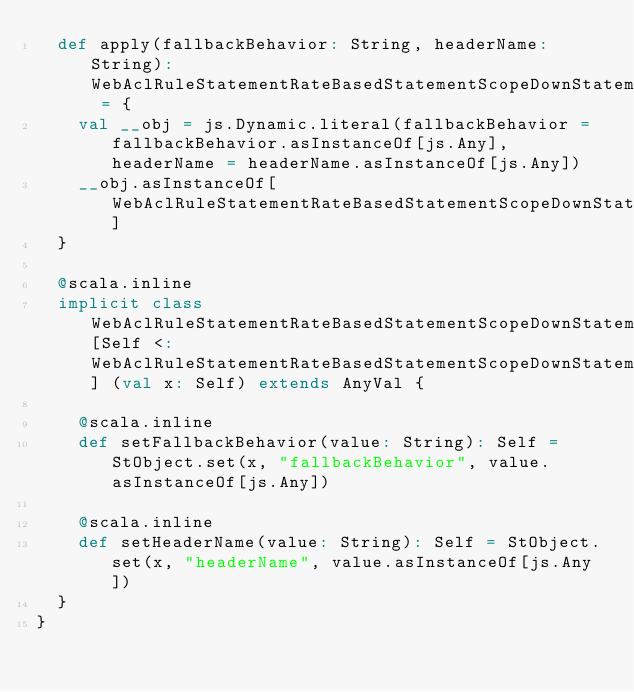<code> <loc_0><loc_0><loc_500><loc_500><_Scala_>  def apply(fallbackBehavior: String, headerName: String): WebAclRuleStatementRateBasedStatementScopeDownStatementNotStatementStatementNotStatementStatementGeoMatchStatementForwardedIpConfig = {
    val __obj = js.Dynamic.literal(fallbackBehavior = fallbackBehavior.asInstanceOf[js.Any], headerName = headerName.asInstanceOf[js.Any])
    __obj.asInstanceOf[WebAclRuleStatementRateBasedStatementScopeDownStatementNotStatementStatementNotStatementStatementGeoMatchStatementForwardedIpConfig]
  }
  
  @scala.inline
  implicit class WebAclRuleStatementRateBasedStatementScopeDownStatementNotStatementStatementNotStatementStatementGeoMatchStatementForwardedIpConfigMutableBuilder[Self <: WebAclRuleStatementRateBasedStatementScopeDownStatementNotStatementStatementNotStatementStatementGeoMatchStatementForwardedIpConfig] (val x: Self) extends AnyVal {
    
    @scala.inline
    def setFallbackBehavior(value: String): Self = StObject.set(x, "fallbackBehavior", value.asInstanceOf[js.Any])
    
    @scala.inline
    def setHeaderName(value: String): Self = StObject.set(x, "headerName", value.asInstanceOf[js.Any])
  }
}
</code> 